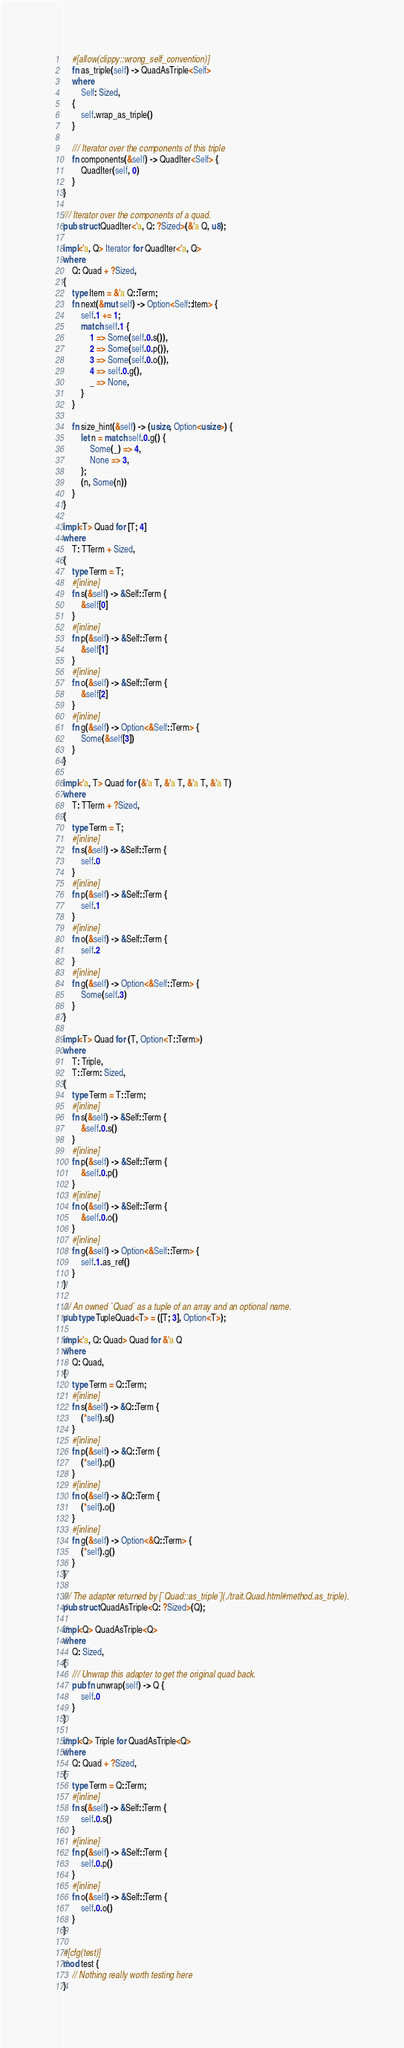<code> <loc_0><loc_0><loc_500><loc_500><_Rust_>    #[allow(clippy::wrong_self_convention)]
    fn as_triple(self) -> QuadAsTriple<Self>
    where
        Self: Sized,
    {
        self.wrap_as_triple()
    }

    /// Iterator over the components of this triple
    fn components(&self) -> QuadIter<Self> {
        QuadIter(self, 0)
    }
}

/// Iterator over the components of a quad.
pub struct QuadIter<'a, Q: ?Sized>(&'a Q, u8);

impl<'a, Q> Iterator for QuadIter<'a, Q>
where
    Q: Quad + ?Sized,
{
    type Item = &'a Q::Term;
    fn next(&mut self) -> Option<Self::Item> {
        self.1 += 1;
        match self.1 {
            1 => Some(self.0.s()),
            2 => Some(self.0.p()),
            3 => Some(self.0.o()),
            4 => self.0.g(),
            _ => None,
        }
    }

    fn size_hint(&self) -> (usize, Option<usize>) {
        let n = match self.0.g() {
            Some(_) => 4,
            None => 3,
        };
        (n, Some(n))
    }
}

impl<T> Quad for [T; 4]
where
    T: TTerm + Sized,
{
    type Term = T;
    #[inline]
    fn s(&self) -> &Self::Term {
        &self[0]
    }
    #[inline]
    fn p(&self) -> &Self::Term {
        &self[1]
    }
    #[inline]
    fn o(&self) -> &Self::Term {
        &self[2]
    }
    #[inline]
    fn g(&self) -> Option<&Self::Term> {
        Some(&self[3])
    }
}

impl<'a, T> Quad for (&'a T, &'a T, &'a T, &'a T)
where
    T: TTerm + ?Sized,
{
    type Term = T;
    #[inline]
    fn s(&self) -> &Self::Term {
        self.0
    }
    #[inline]
    fn p(&self) -> &Self::Term {
        self.1
    }
    #[inline]
    fn o(&self) -> &Self::Term {
        self.2
    }
    #[inline]
    fn g(&self) -> Option<&Self::Term> {
        Some(self.3)
    }
}

impl<T> Quad for (T, Option<T::Term>)
where
    T: Triple,
    T::Term: Sized,
{
    type Term = T::Term;
    #[inline]
    fn s(&self) -> &Self::Term {
        &self.0.s()
    }
    #[inline]
    fn p(&self) -> &Self::Term {
        &self.0.p()
    }
    #[inline]
    fn o(&self) -> &Self::Term {
        &self.0.o()
    }
    #[inline]
    fn g(&self) -> Option<&Self::Term> {
        self.1.as_ref()
    }
}

/// An owned `Quad` as a tuple of an array and an optional name.
pub type TupleQuad<T> = ([T; 3], Option<T>);

impl<'a, Q: Quad> Quad for &'a Q
where
    Q: Quad,
{
    type Term = Q::Term;
    #[inline]
    fn s(&self) -> &Q::Term {
        (*self).s()
    }
    #[inline]
    fn p(&self) -> &Q::Term {
        (*self).p()
    }
    #[inline]
    fn o(&self) -> &Q::Term {
        (*self).o()
    }
    #[inline]
    fn g(&self) -> Option<&Q::Term> {
        (*self).g()
    }
}

/// The adapter returned by [`Quad::as_triple`](./trait.Quad.html#method.as_triple).
pub struct QuadAsTriple<Q: ?Sized>(Q);

impl<Q> QuadAsTriple<Q>
where
    Q: Sized,
{
    /// Unwrap this adapter to get the original quad back.
    pub fn unwrap(self) -> Q {
        self.0
    }
}

impl<Q> Triple for QuadAsTriple<Q>
where
    Q: Quad + ?Sized,
{
    type Term = Q::Term;
    #[inline]
    fn s(&self) -> &Self::Term {
        self.0.s()
    }
    #[inline]
    fn p(&self) -> &Self::Term {
        self.0.p()
    }
    #[inline]
    fn o(&self) -> &Self::Term {
        self.0.o()
    }
}

#[cfg(test)]
mod test {
    // Nothing really worth testing here
}
</code> 